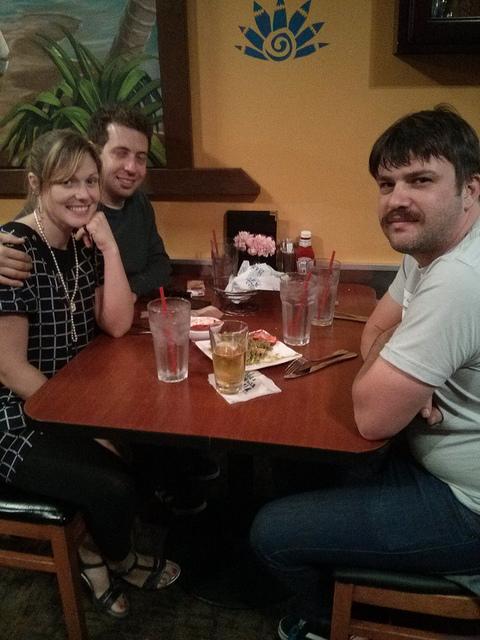How many glasses of water on the table?
Write a very short answer. 3. Are the people eating?
Quick response, please. No. Is the woman wearing pants?
Answer briefly. Yes. What is on the man on the right's forearm?
Short answer required. Nothing. What color is the shirt the man on the right is wearing?
Keep it brief. White. How many people are wearing glasses?
Answer briefly. 0. Do the glasses need to be filled?
Give a very brief answer. No. Are some people drinking wine?
Give a very brief answer. No. What color is his drink?
Short answer required. Yellow. What is the blue paint pattern on the wall?
Keep it brief. Feathers. What is the lady drinking?
Short answer required. Water. How many people in the photo?
Concise answer only. 3. 